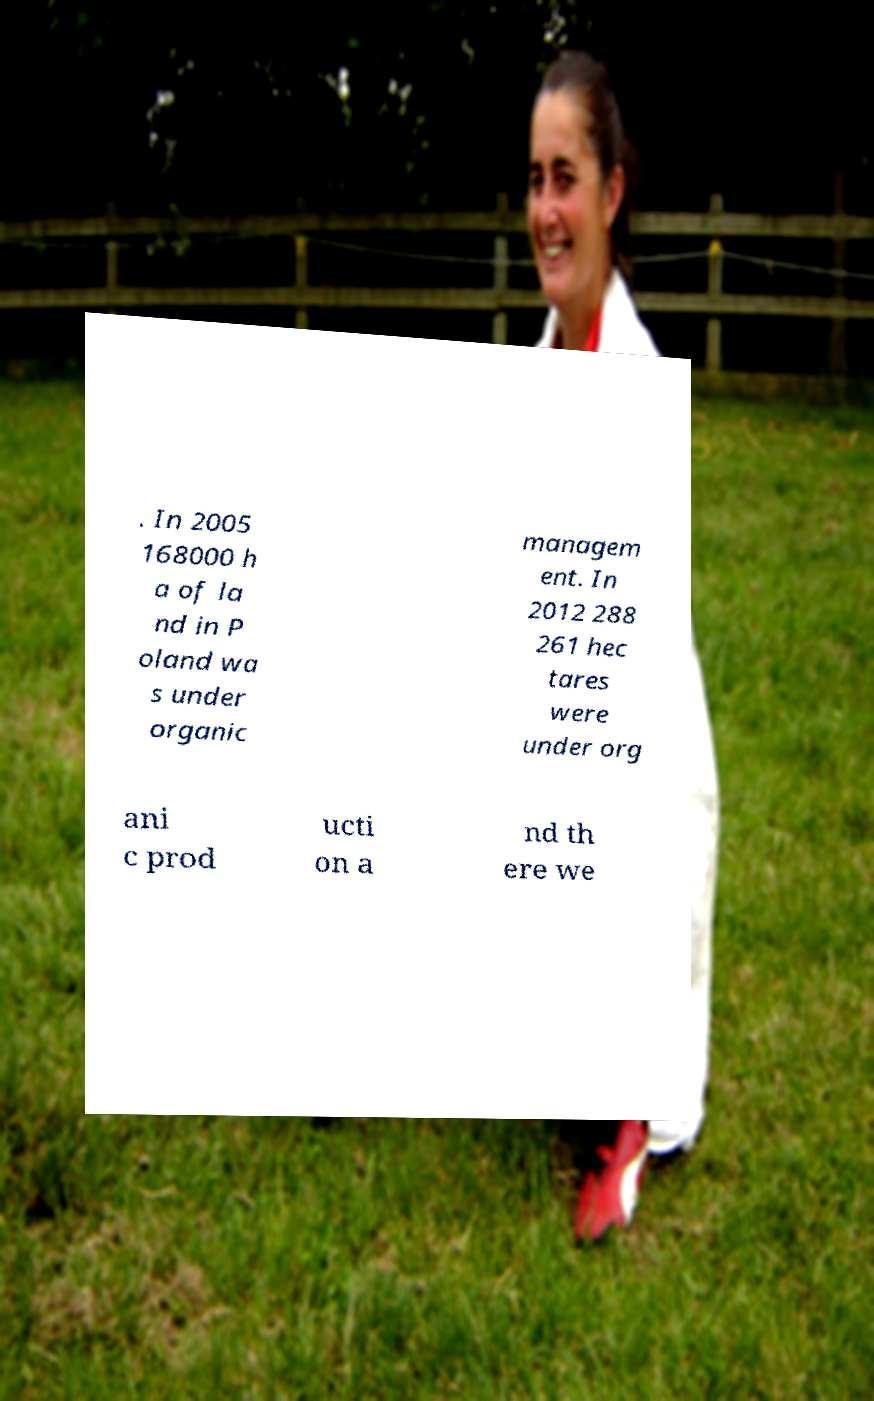Could you extract and type out the text from this image? . In 2005 168000 h a of la nd in P oland wa s under organic managem ent. In 2012 288 261 hec tares were under org ani c prod ucti on a nd th ere we 